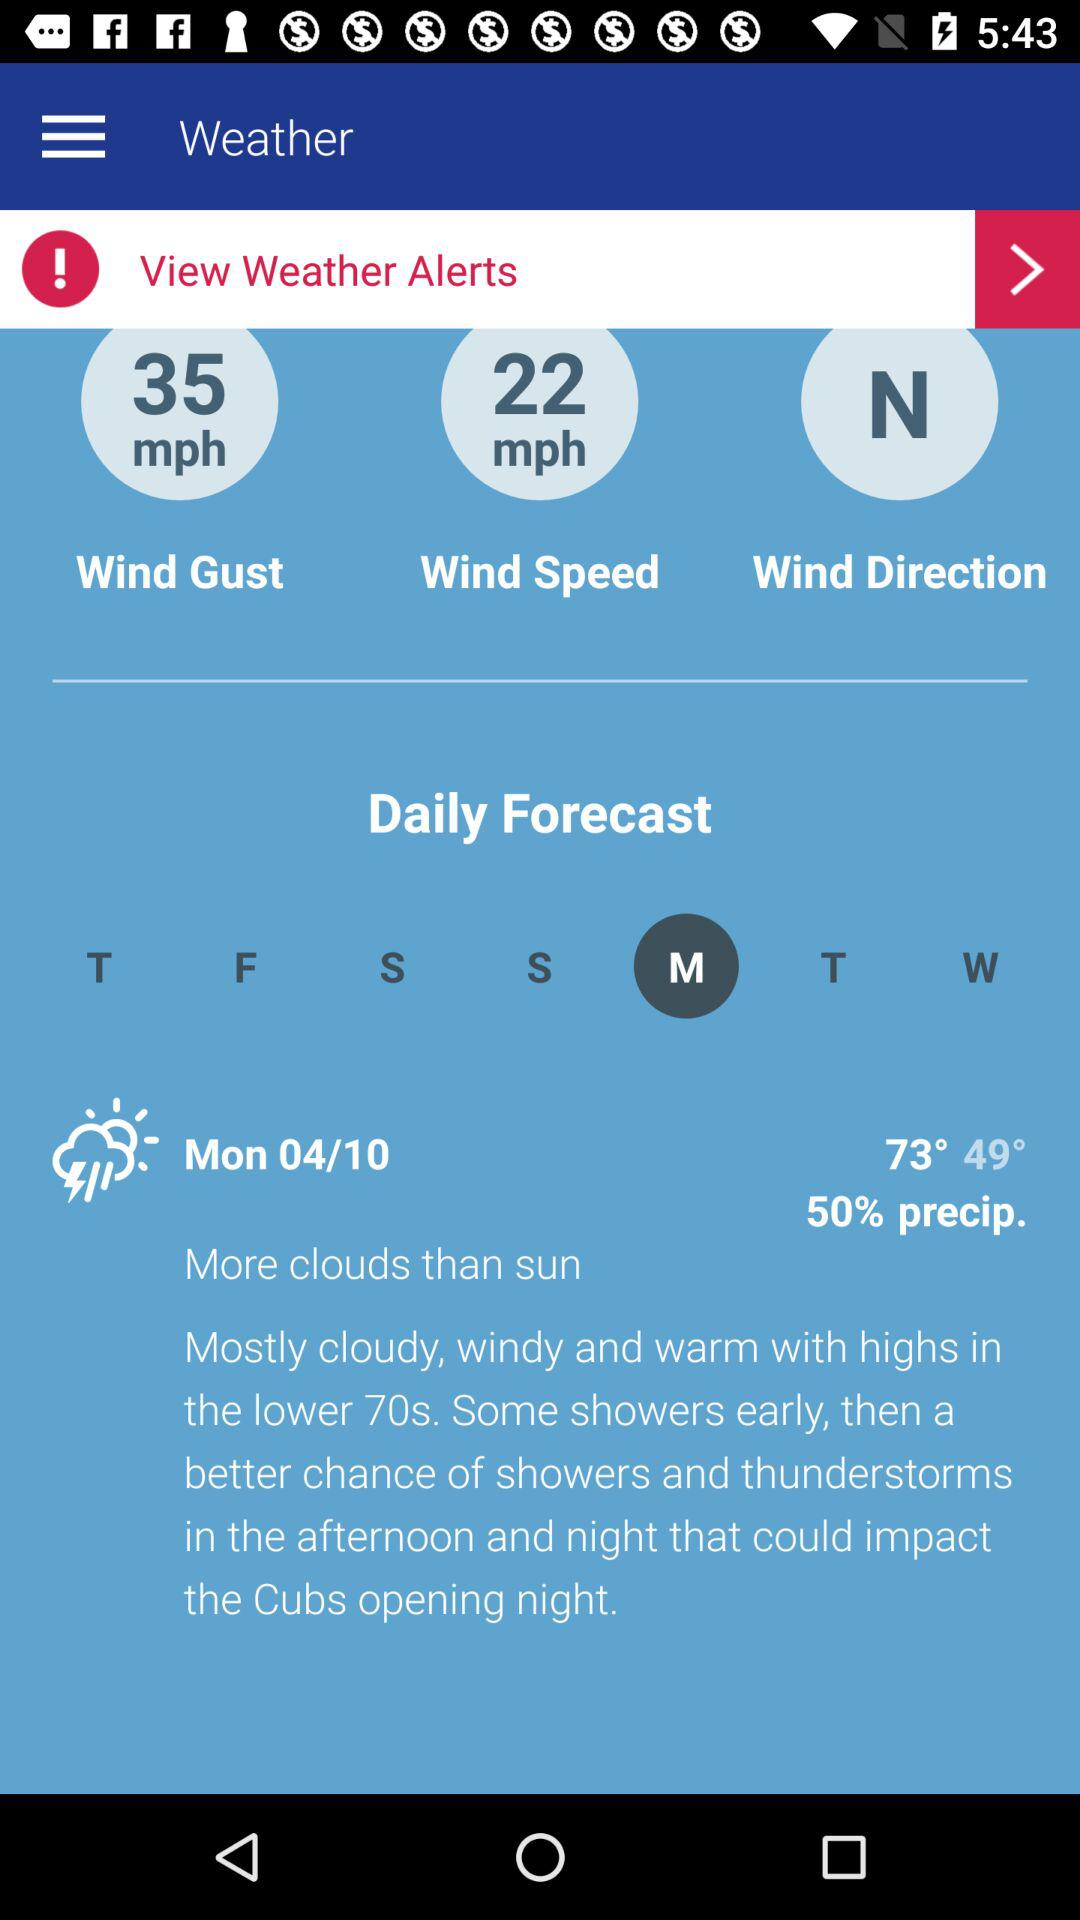What is the wind direction? The direction of the wind is north. 